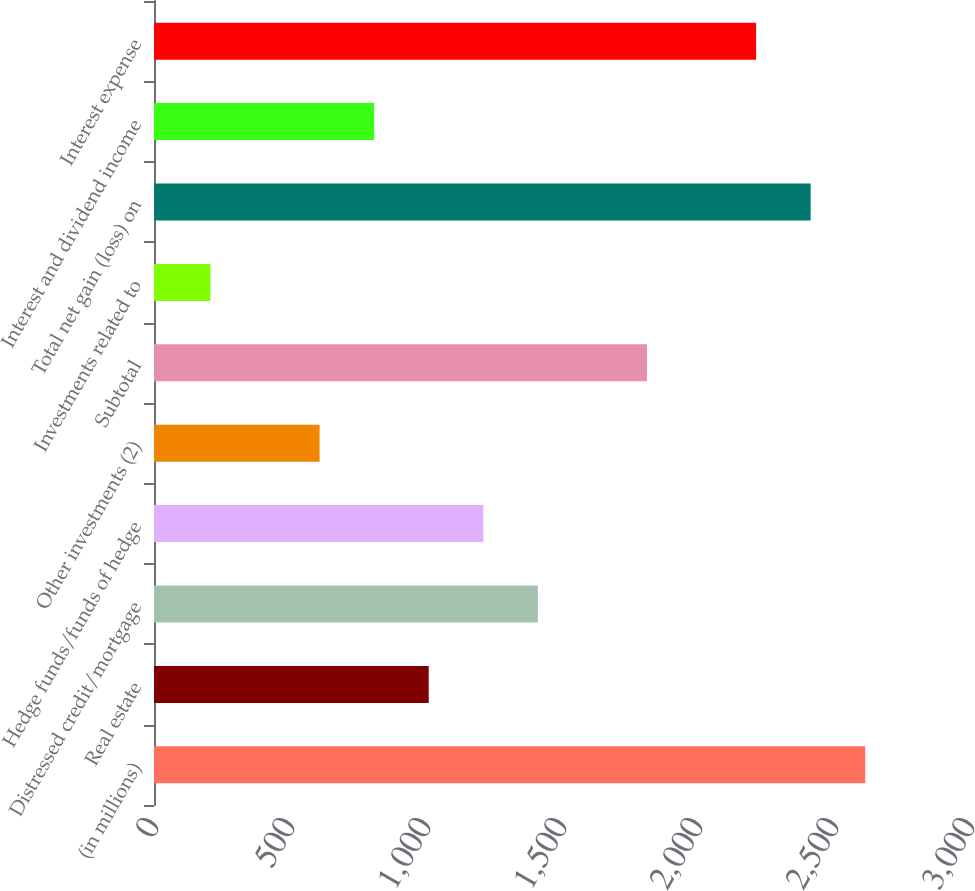Convert chart to OTSL. <chart><loc_0><loc_0><loc_500><loc_500><bar_chart><fcel>(in millions)<fcel>Real estate<fcel>Distressed credit/mortgage<fcel>Hedge funds/funds of hedge<fcel>Other investments (2)<fcel>Subtotal<fcel>Investments related to<fcel>Total net gain (loss) on<fcel>Interest and dividend income<fcel>Interest expense<nl><fcel>2614.8<fcel>1010<fcel>1411.2<fcel>1210.6<fcel>608.8<fcel>1812.4<fcel>207.6<fcel>2414.2<fcel>809.4<fcel>2213.6<nl></chart> 